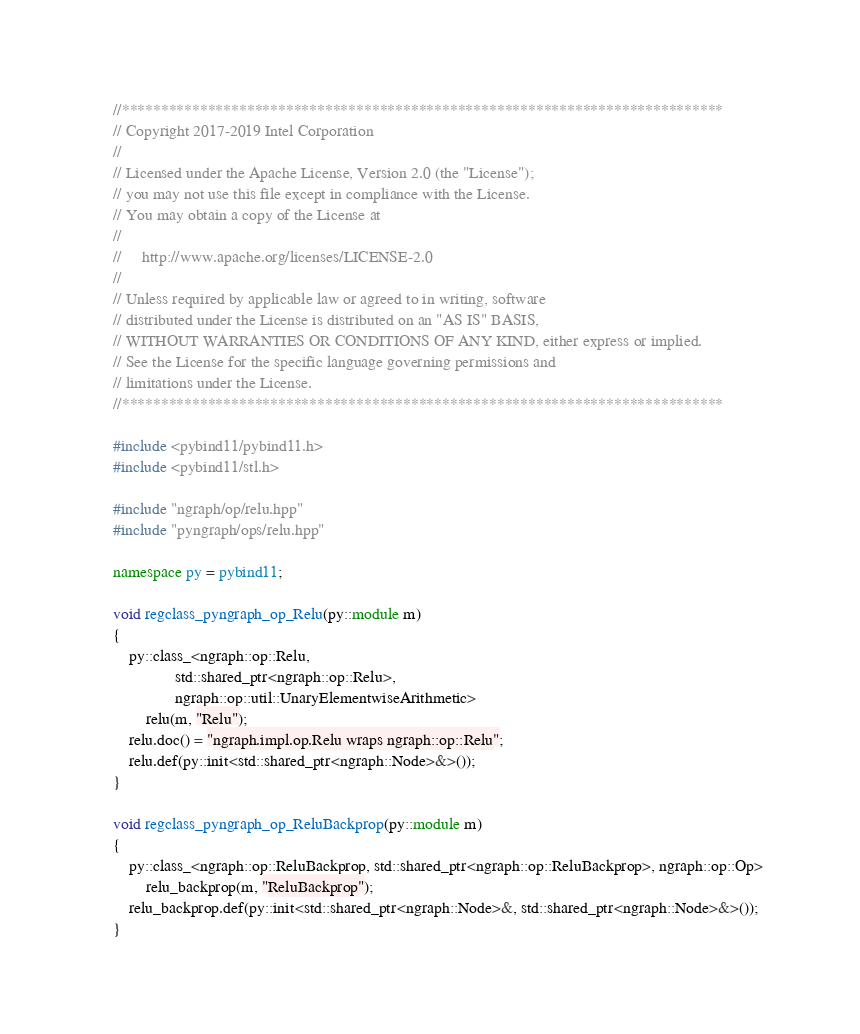<code> <loc_0><loc_0><loc_500><loc_500><_C++_>//*****************************************************************************
// Copyright 2017-2019 Intel Corporation
//
// Licensed under the Apache License, Version 2.0 (the "License");
// you may not use this file except in compliance with the License.
// You may obtain a copy of the License at
//
//     http://www.apache.org/licenses/LICENSE-2.0
//
// Unless required by applicable law or agreed to in writing, software
// distributed under the License is distributed on an "AS IS" BASIS,
// WITHOUT WARRANTIES OR CONDITIONS OF ANY KIND, either express or implied.
// See the License for the specific language governing permissions and
// limitations under the License.
//*****************************************************************************

#include <pybind11/pybind11.h>
#include <pybind11/stl.h>

#include "ngraph/op/relu.hpp"
#include "pyngraph/ops/relu.hpp"

namespace py = pybind11;

void regclass_pyngraph_op_Relu(py::module m)
{
    py::class_<ngraph::op::Relu,
               std::shared_ptr<ngraph::op::Relu>,
               ngraph::op::util::UnaryElementwiseArithmetic>
        relu(m, "Relu");
    relu.doc() = "ngraph.impl.op.Relu wraps ngraph::op::Relu";
    relu.def(py::init<std::shared_ptr<ngraph::Node>&>());
}

void regclass_pyngraph_op_ReluBackprop(py::module m)
{
    py::class_<ngraph::op::ReluBackprop, std::shared_ptr<ngraph::op::ReluBackprop>, ngraph::op::Op>
        relu_backprop(m, "ReluBackprop");
    relu_backprop.def(py::init<std::shared_ptr<ngraph::Node>&, std::shared_ptr<ngraph::Node>&>());
}
</code> 